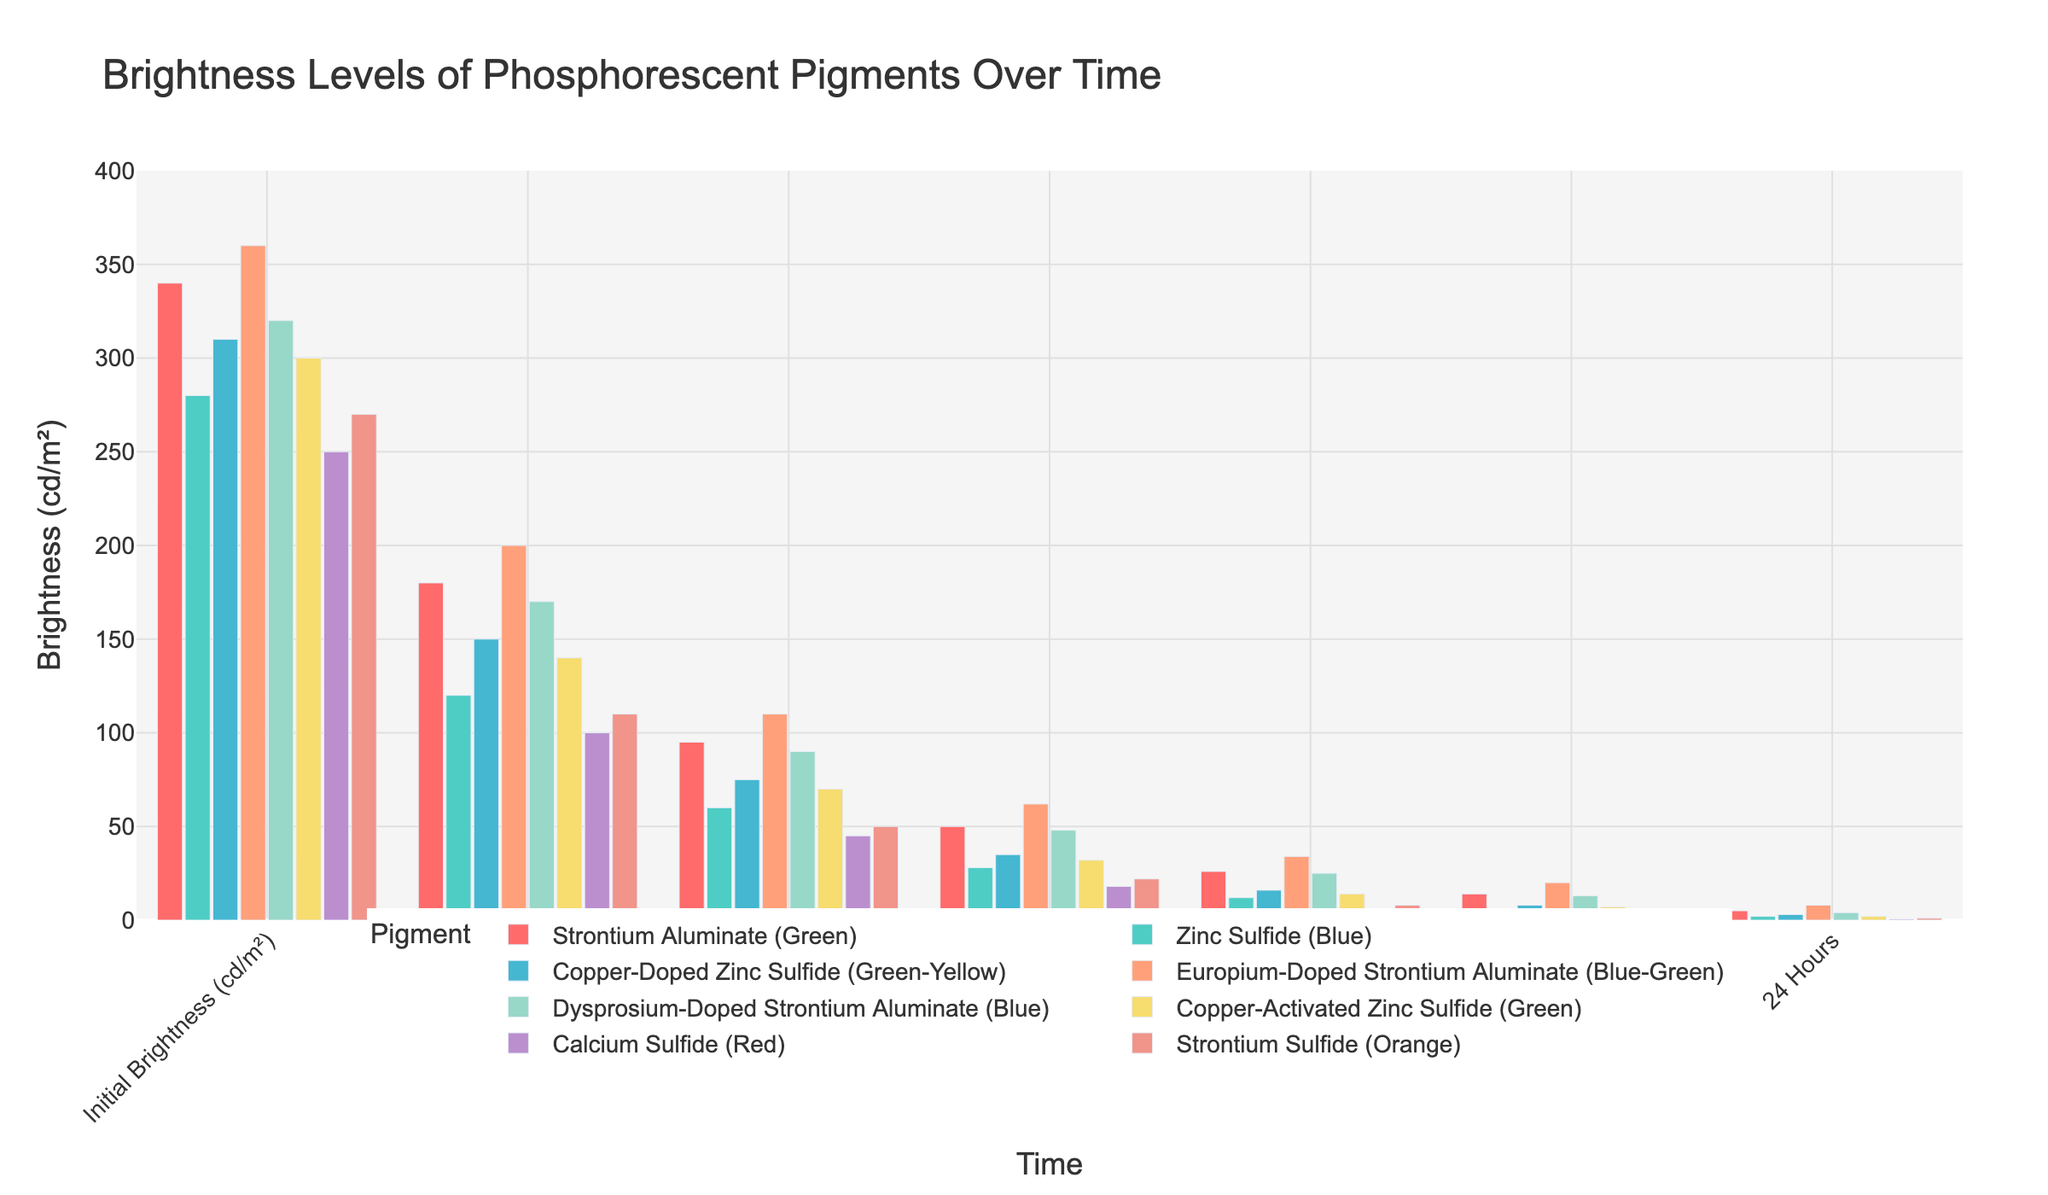Which pigment has the highest initial brightness? The plot shows the initial brightness levels of all pigments. Europium-Doped Strontium Aluminate (Blue-Green) has the bar with the highest height at the initial point.
Answer: Europium-Doped Strontium Aluminate (Blue-Green) How does the brightness of Zinc Sulfide (Blue) compare to Calcium Sulfide (Red) after 2 hours? Look at the bars for Zinc Sulfide (Blue) and Calcium Sulfide (Red) at the 2-hour mark. Zinc Sulfide (Blue) has a brightness of 60 cd/m², whereas Calcium Sulfide (Red) has 45 cd/m².
Answer: Zinc Sulfide (Blue) is brighter What is the difference in brightness between Strontium Aluminate (Green) and Copper-Activated Zinc Sulfide (Green) at 8 hours? At the 8-hour mark, Strontium Aluminate (Green) has a brightness of 26 cd/m², and Copper-Activated Zinc Sulfide (Green) has 14 cd/m². The difference is 26 - 14.
Answer: 12 cd/m² Which pigment has the lowest brightness at the 24-hour mark? Look at the bars for all pigments at the 24-hour mark. Calcium Sulfide (Red) has the lowest bar height.
Answer: Calcium Sulfide (Red) What's the average initial brightness of all pigments? Add the initial brightness of all pigments and divide by the number of pigments: (340 + 280 + 310 + 360 + 320 + 300 + 250 + 270) / 8.
Answer: 303.75 cd/m² What is the overall trend in brightness for Dysprosium-Doped Strontium Aluminate (Blue) over time? Dysprosium-Doped Strontium Aluminate (Blue) shows a continuous decrease in brightness from its initial value through all time points.
Answer: Decreasing trend After 1 hour, which pigment has the second highest brightness? Look at the bars for all pigments after 1 hour. Europium-Doped Strontium Aluminate (Blue-Green) is the highest, and Strontium Aluminate (Green) is the next highest.
Answer: Strontium Aluminate (Green) How does the change in brightness from initial to 4 hours compare between Strontium Sulfide (Orange) and Zinc Sulfide (Blue)? Calculate the change for both pigments: Strontium Sulfide (Orange) goes from 270 to 22 (change = 248) and Zinc Sulfide (Blue) goes from 280 to 28 (change = 252). Compare these changes.
Answer: Zinc Sulfide (Blue) decreases more At 12 hours, list the pigments with a brightness of 10 cd/m² or higher. Look at the bars for all pigments at 12 hours. Check which bars have values of 10 cd/m² or higher.
Answer: Europium-Doped Strontium Aluminate (Blue-Green), Strontium Aluminate (Green), and Dysprosium-Doped Strontium Aluminate (Blue) Which pigments have their brightness reduced by more than half after 1 hour? For each pigment, see if its brightness after 1 hour is less than half its initial brightness. Examples: Strontium Aluminate (Green) 340 to 180, Zinc Sulfide (Blue) 280 to 120 (both are less than half). Apply this checking for all pigments.
Answer: Zinc Sulfide (Blue), Calcium Sulfide (Red), and Strontium Sulfide (Orange) 